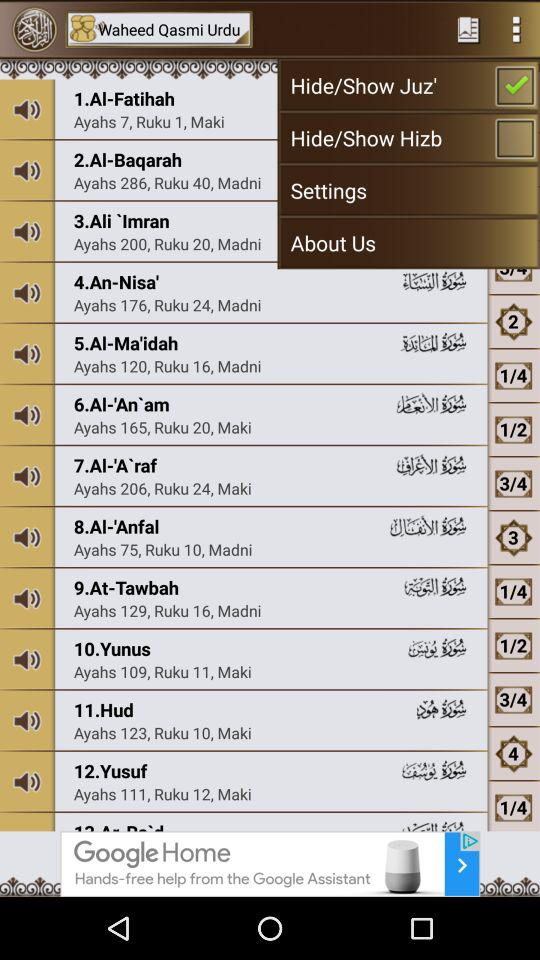Which of the checkboxes has been checked? The checked checkbox is "Hide/Show Juz'". 